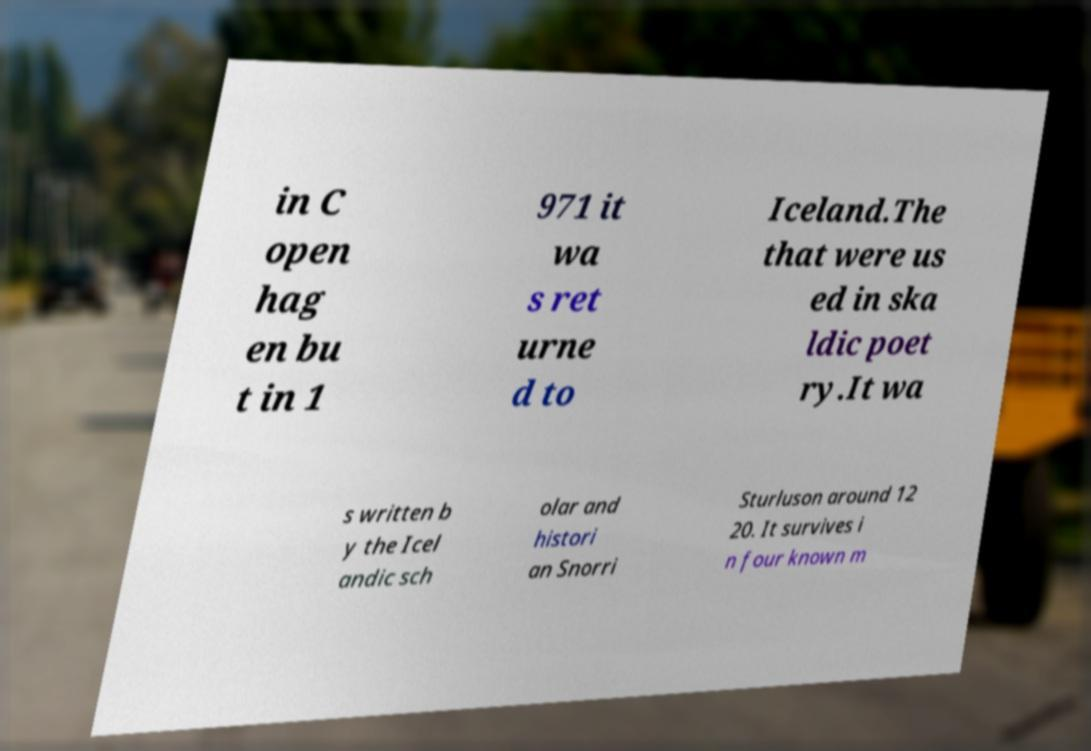Please identify and transcribe the text found in this image. in C open hag en bu t in 1 971 it wa s ret urne d to Iceland.The that were us ed in ska ldic poet ry.It wa s written b y the Icel andic sch olar and histori an Snorri Sturluson around 12 20. It survives i n four known m 